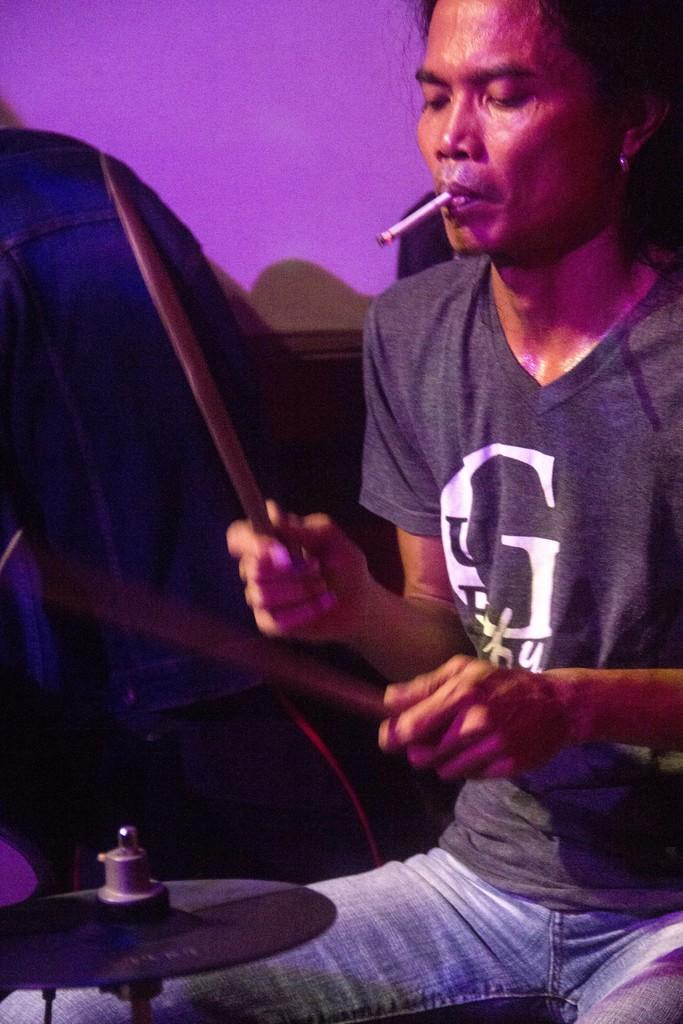<image>
Relay a brief, clear account of the picture shown. The man wearing a shirt with a G on it is playing the drums and smoking a cigarette. 